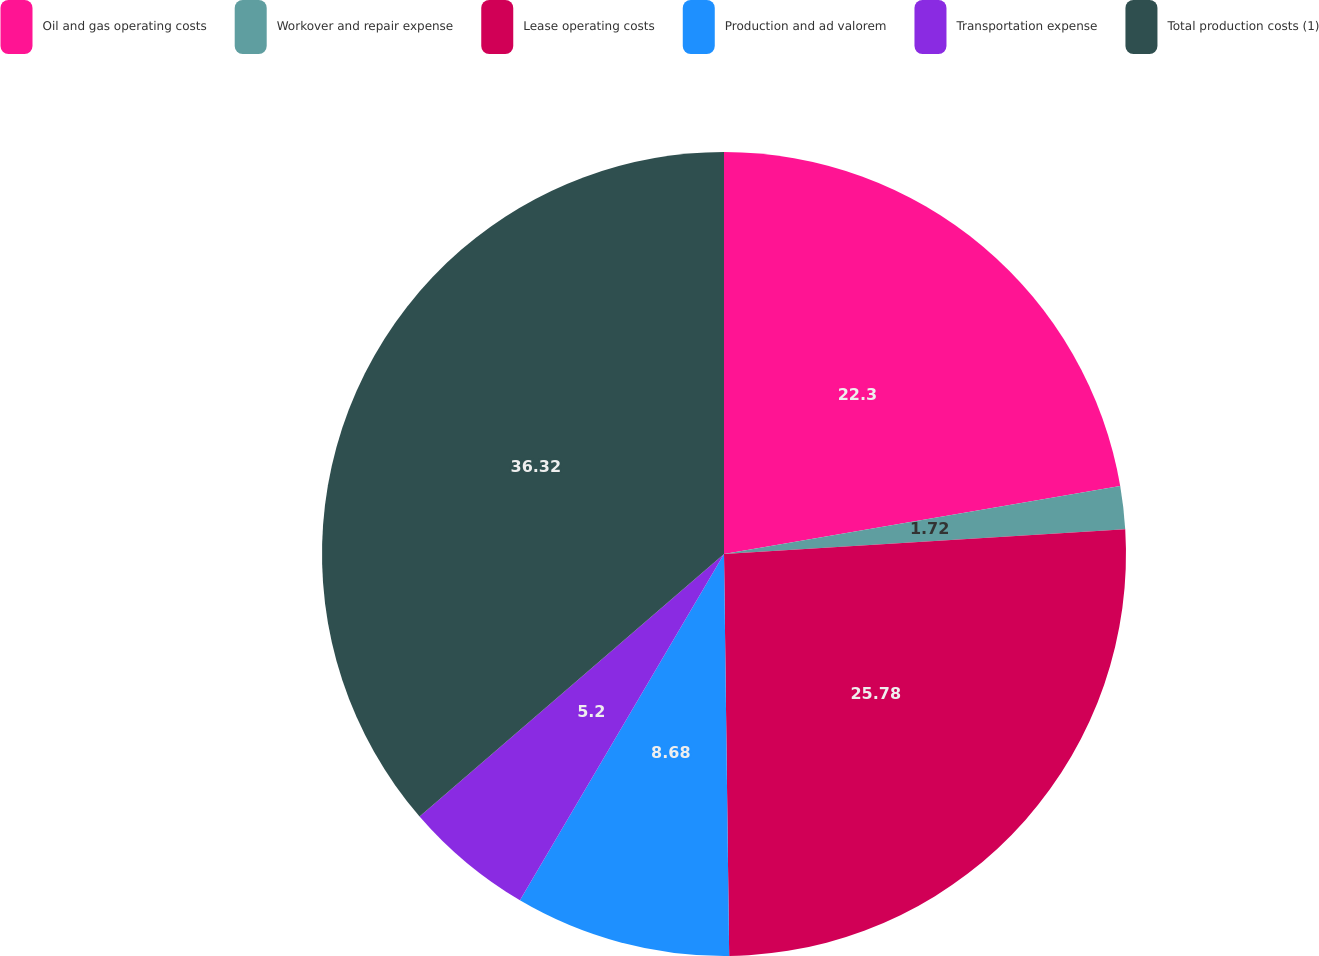Convert chart. <chart><loc_0><loc_0><loc_500><loc_500><pie_chart><fcel>Oil and gas operating costs<fcel>Workover and repair expense<fcel>Lease operating costs<fcel>Production and ad valorem<fcel>Transportation expense<fcel>Total production costs (1)<nl><fcel>22.3%<fcel>1.72%<fcel>25.78%<fcel>8.68%<fcel>5.2%<fcel>36.33%<nl></chart> 